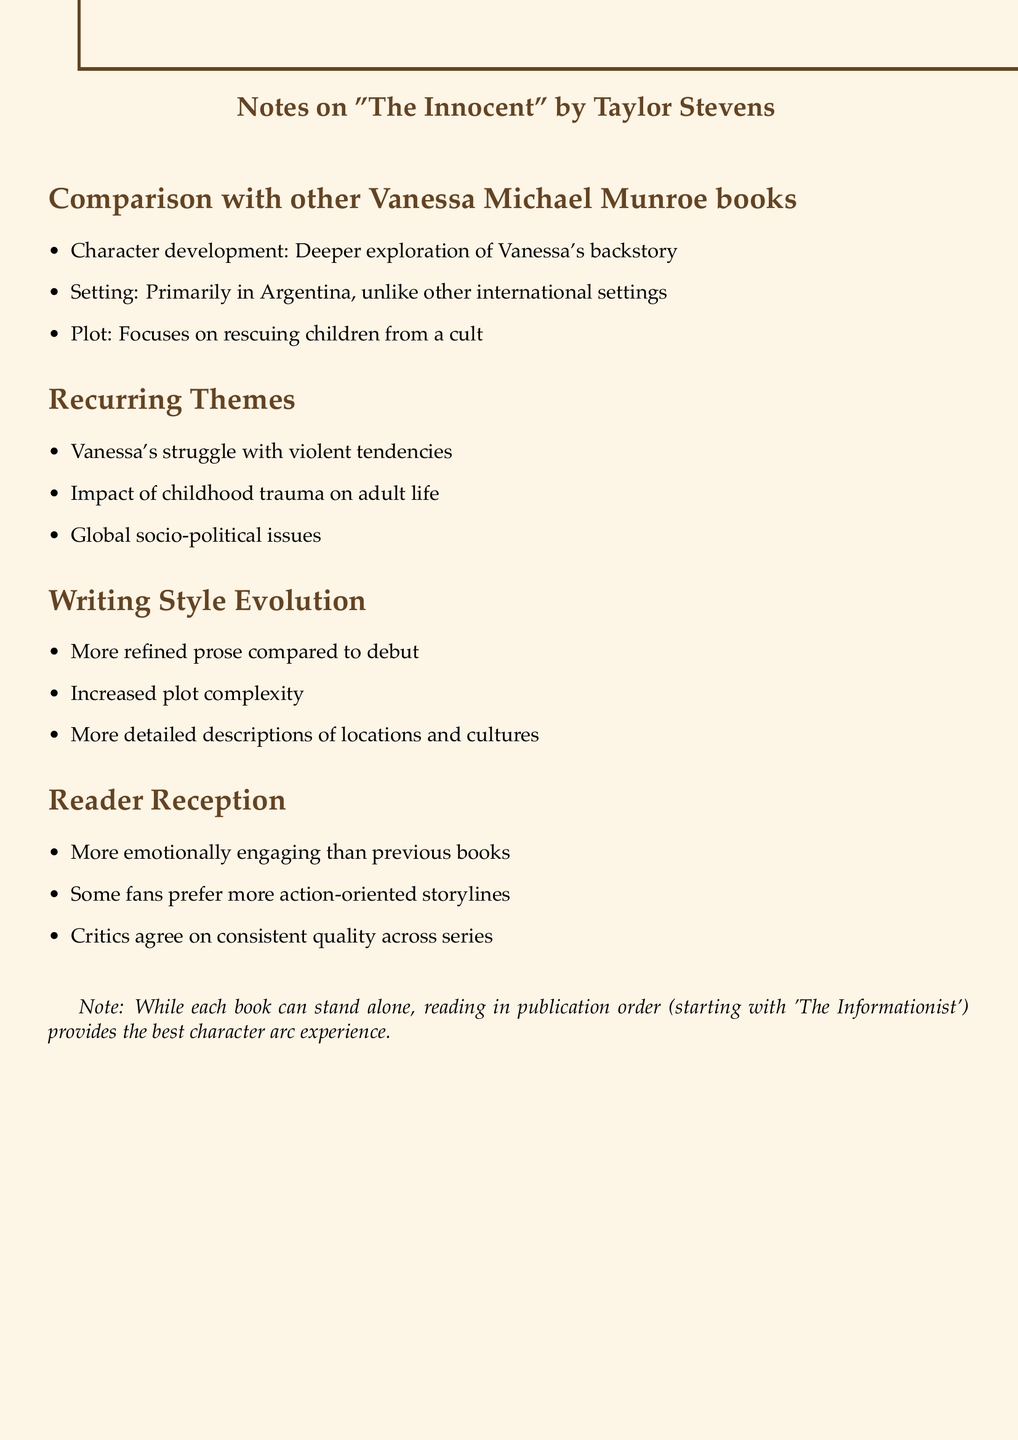What is the main setting of "The Innocent"? The document states that "The Innocent" primarily takes place in Argentina.
Answer: Argentina What is the plot focus of "The Innocent"? The plot of "The Innocent" is centered around rescuing children from a cult, as mentioned in the document.
Answer: Rescuing children from a cult Which book is the debut in the Vanessa Michael Munroe series? The document mentions 'The Informationist' as the first book in the series.
Answer: The Informationist What theme involves Vanessa's childhood? The document notes the impact of childhood trauma on adult life as a recurring theme.
Answer: Impact of childhood trauma on adult life How does the writing style of "The Innocent" compare to the first book? The document indicates that Taylor Stevens' prose becomes more refined in 'The Innocent' compared to her debut.
Answer: More refined What has been the overall reception of "The Innocent"? The document highlights that many readers find "The Innocent" to be more emotionally engaging than previous books.
Answer: More emotionally engaging How does the plot complexity evolve in the series? The document suggests that there is increased complexity in the plot structure as the series progresses.
Answer: Increased complexity What is a recommended reading strategy for the series? The document recommends reading in publication order for the best character arc experience.
Answer: Reading in publication order 